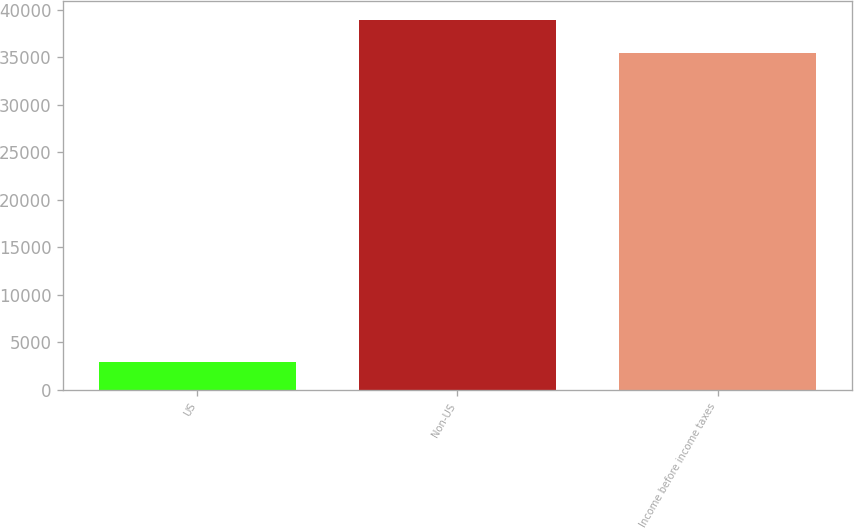Convert chart to OTSL. <chart><loc_0><loc_0><loc_500><loc_500><bar_chart><fcel>US<fcel>Non-US<fcel>Income before income taxes<nl><fcel>2972<fcel>38970.8<fcel>35428<nl></chart> 